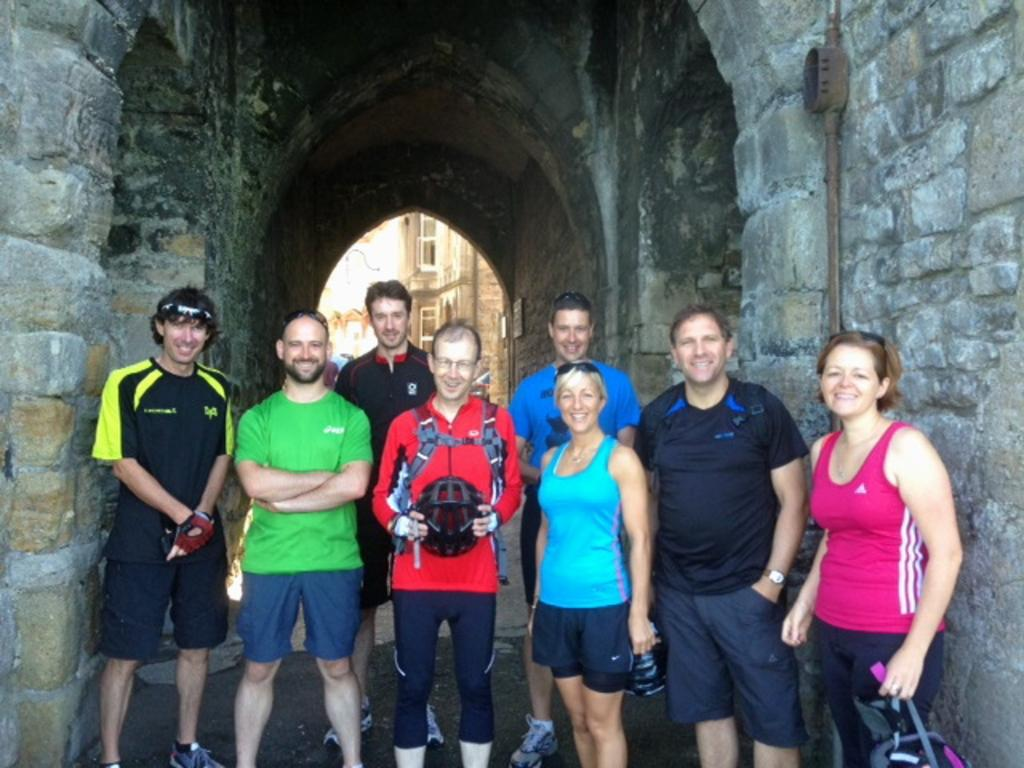What is located in the foreground of the picture? There are people in the foreground of the picture. What type of construction can be seen in the image? There is a construction made up of stones in the image. What can be seen in the center of the background? In the center of the background, there are buildings. Are there any other people visible in the image besides those in the foreground? Yes, people are present in the background of the image. What type of church can be seen on the island in the image? There is no church or island present in the image. How many pages are visible in the image? There are no pages present in the image. 